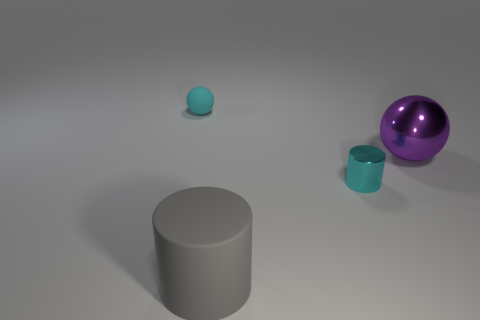What materials do the objects appear to be made of, based on their textures? The large gray object has a rubbery texture indicating it might be made of rubber or a similar material. The tiny cyan ball has a matte finish indicative of a plastic or ceramic material, while the shiny purple sphere has a reflective surface that suggests it's made of metal or glass. 